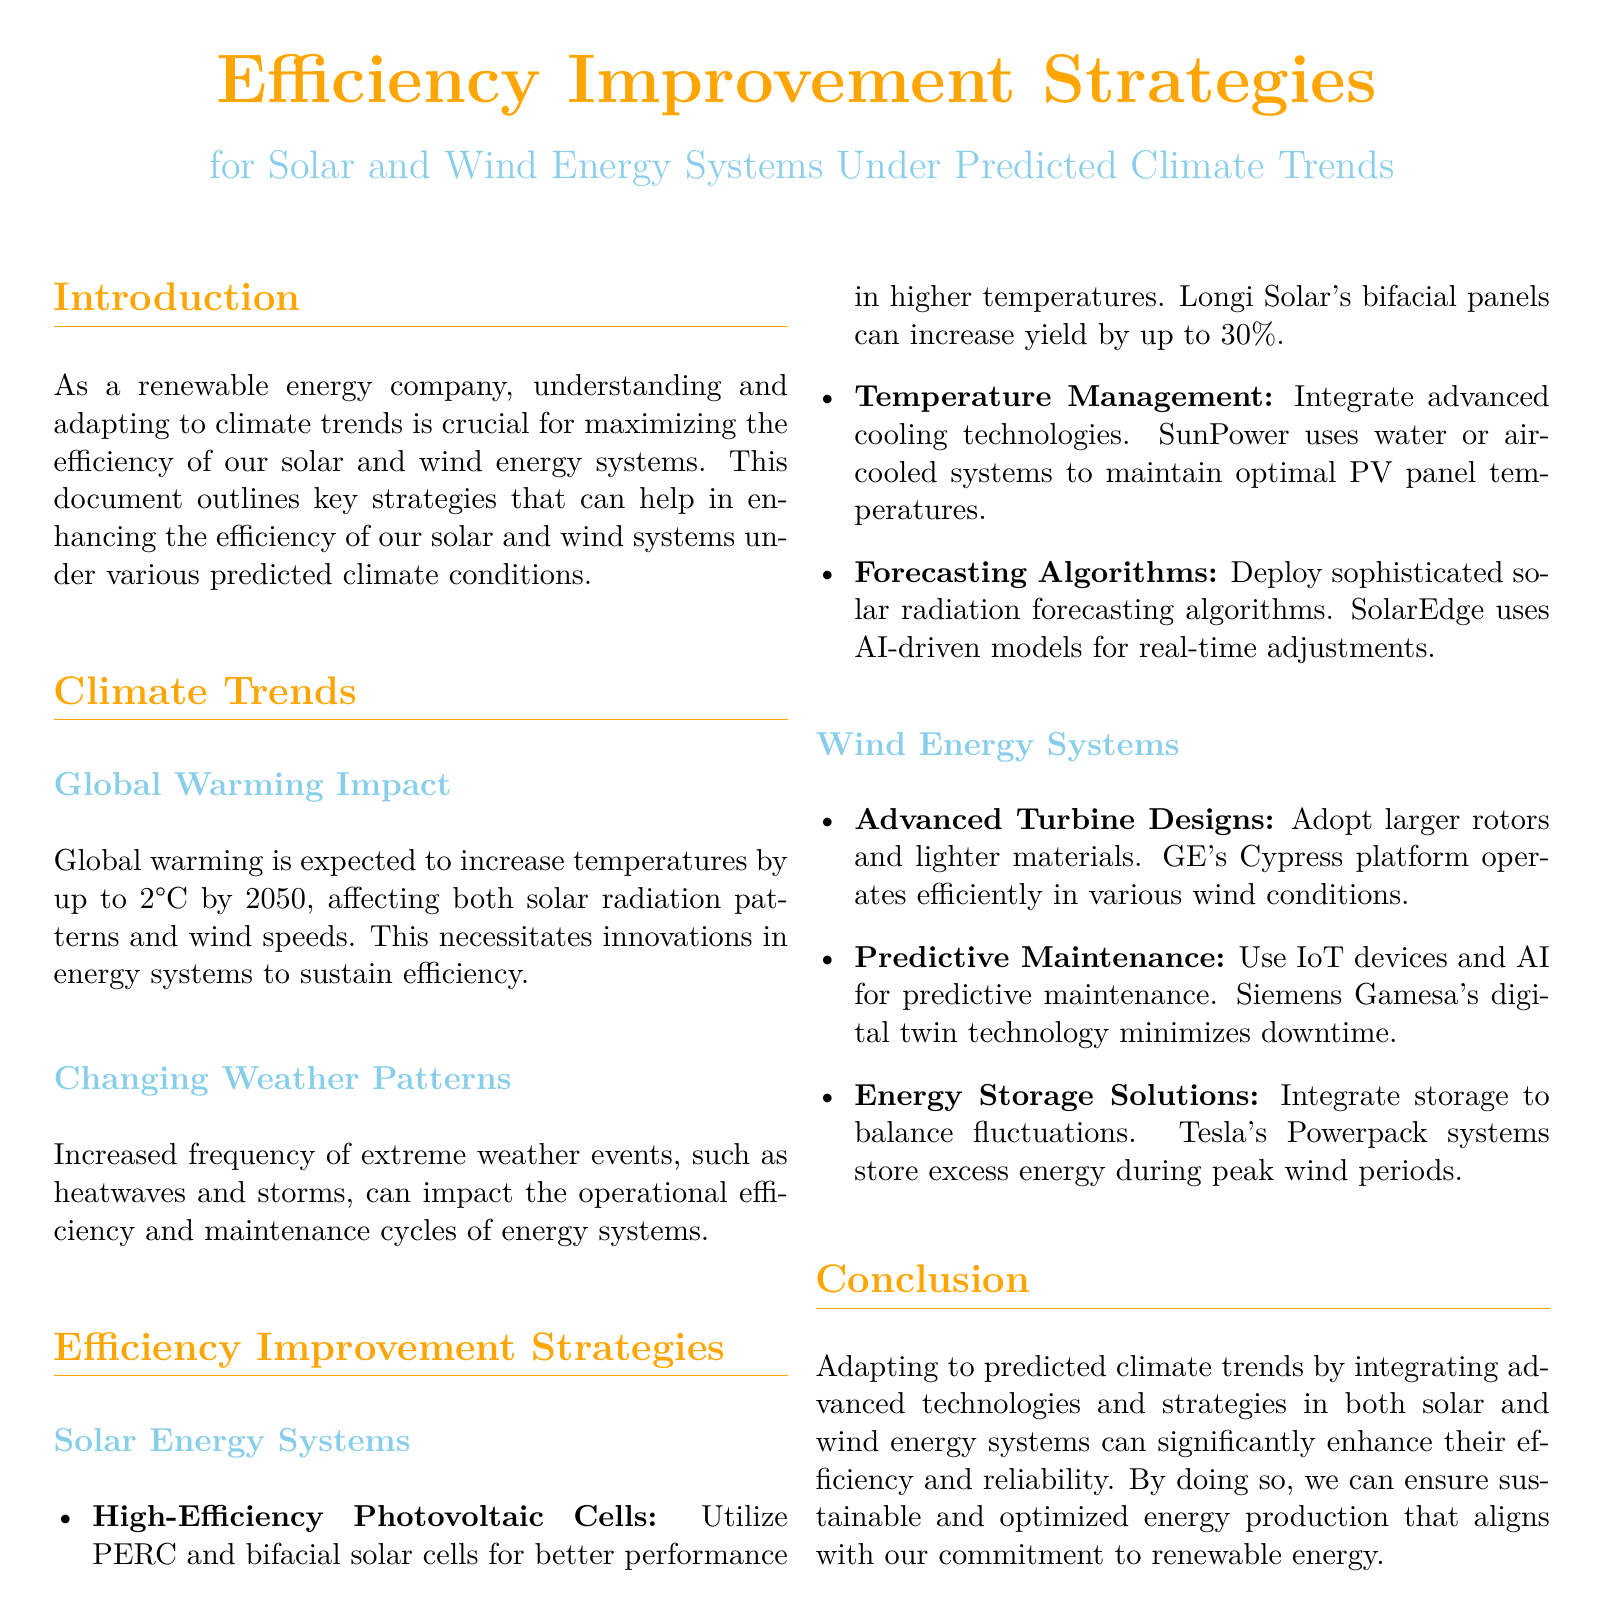What temperature increase is predicted by 2050? The document states that global warming is expected to increase temperatures by up to 2°C by 2050.
Answer: 2°C What type of solar cells can increase yield by up to 30%? The document mentions that Longi Solar's bifacial panels can increase yield by up to 30%.
Answer: Bifacial solar cells Which company uses AI-driven models for real-time adjustments in solar energy systems? The document states that SolarEdge uses AI-driven models for real-time adjustments.
Answer: SolarEdge What technology minimizes downtime in wind energy systems? The document highlights Siemens Gamesa's digital twin technology as a means to minimize downtime.
Answer: Digital twin technology What is one of the advanced cooling technologies mentioned for solar energy systems? The document says SunPower uses water or air-cooled systems to maintain optimal PV panel temperatures.
Answer: Water or air-cooled systems What percentage of higher performance is expected from PERC cells compared to standard cells? The document does not specify a percentage increase in performance, making this a reasoning question requiring comparison and analysis.
Answer: Not specified What is an integrated solution for balancing fluctuations in wind energy? The document mentions Tesla's Powerpack systems as a solution to balance fluctuations.
Answer: Powerpack systems What climate events are predicted to increase in frequency? The document indicates that extreme weather events like heatwaves and storms will occur with increased frequency.
Answer: Extreme weather events What strategy is suggested for temperature management in solar systems? The document recommends integrating advanced cooling technologies for temperature management.
Answer: Advanced cooling technologies 